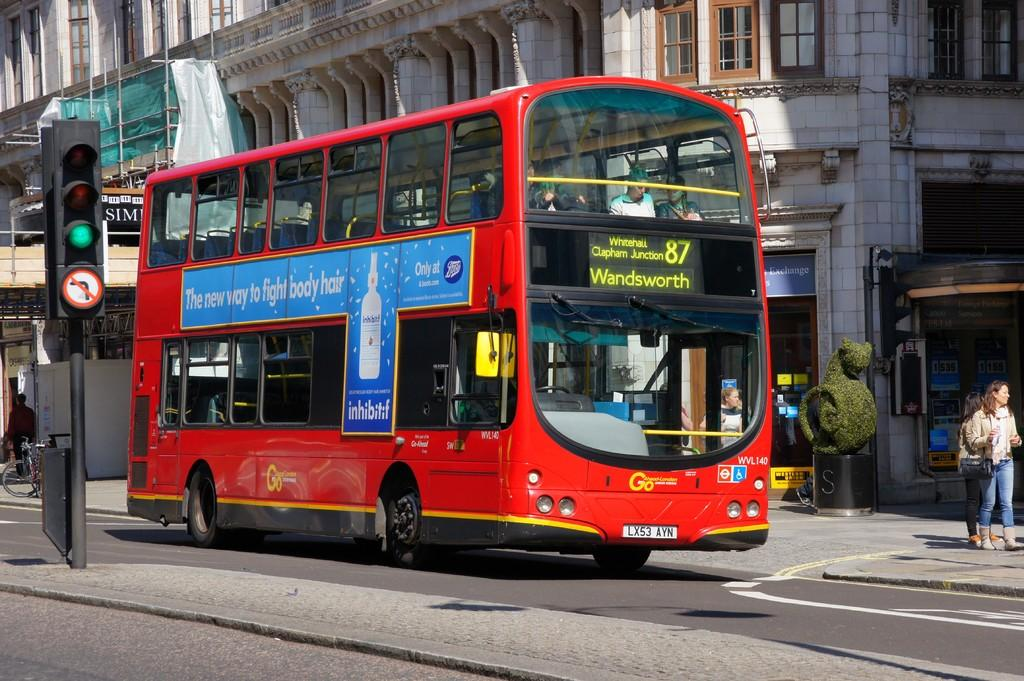<image>
Give a short and clear explanation of the subsequent image. A red bus number 87 is heading to Wandsworth. 